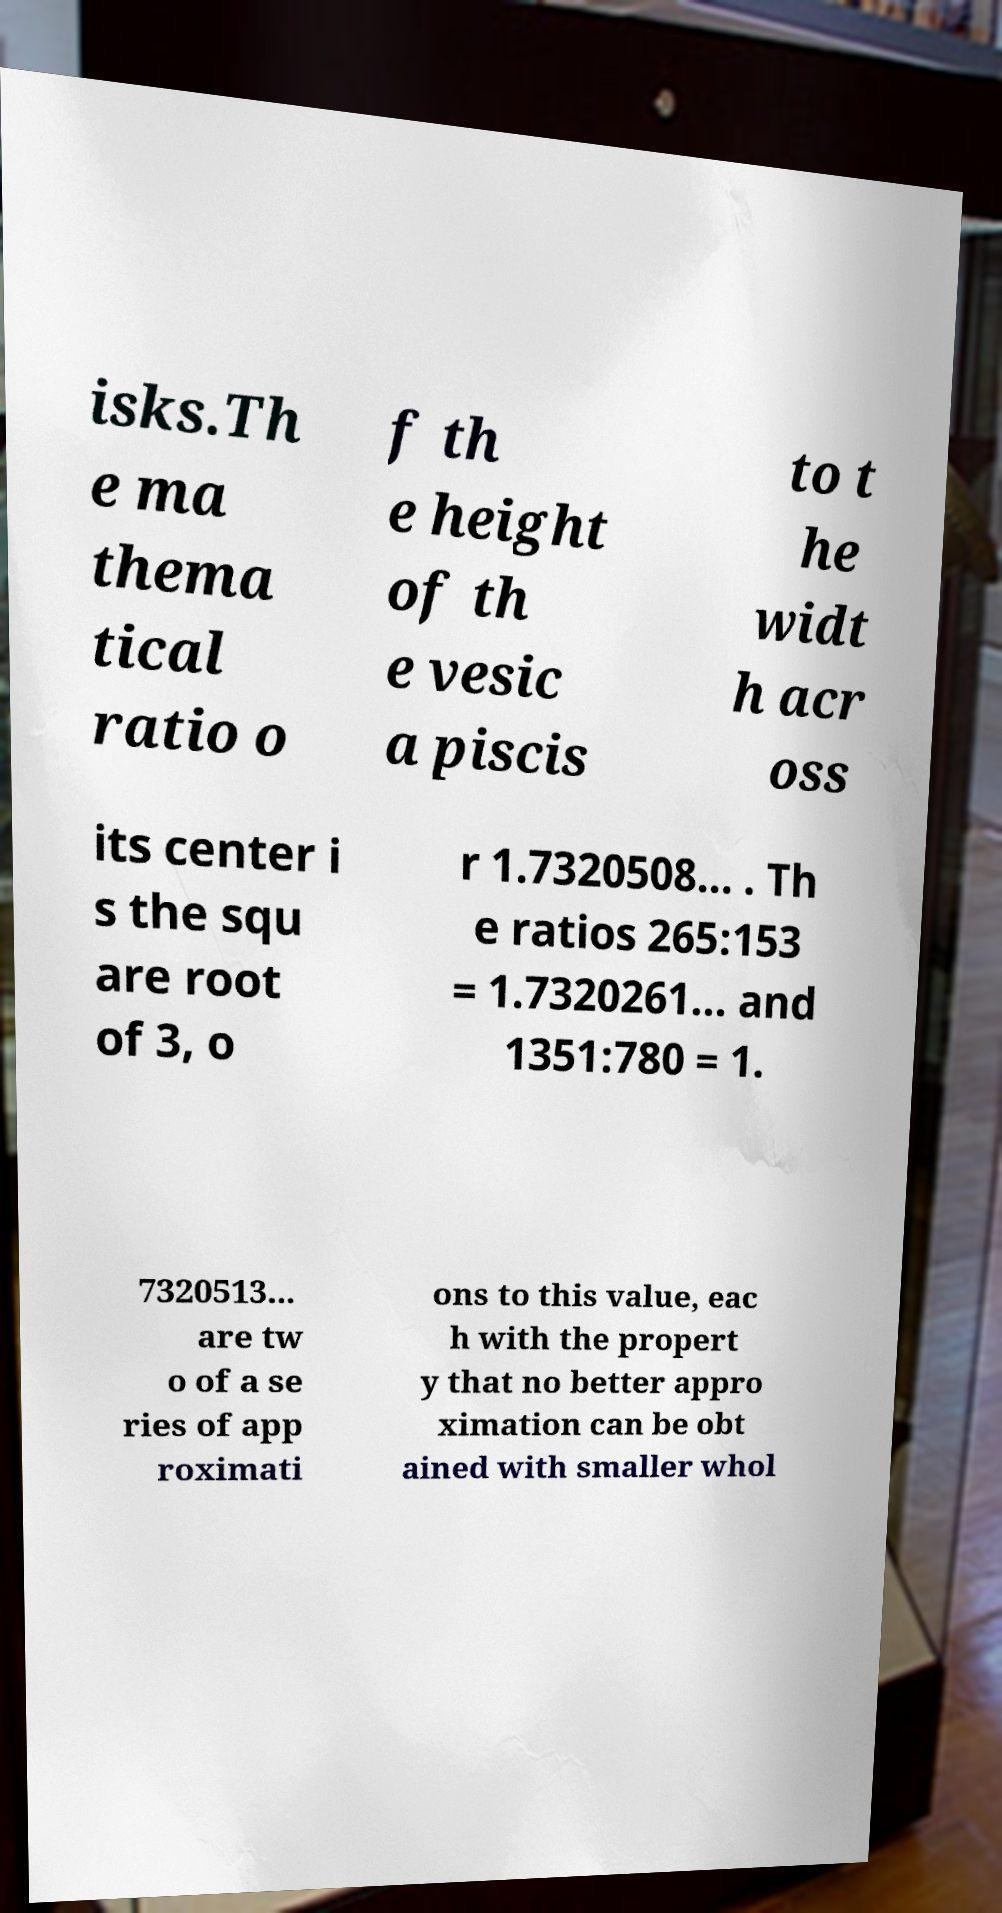Could you extract and type out the text from this image? isks.Th e ma thema tical ratio o f th e height of th e vesic a piscis to t he widt h acr oss its center i s the squ are root of 3, o r 1.7320508... . Th e ratios 265:153 = 1.7320261... and 1351:780 = 1. 7320513... are tw o of a se ries of app roximati ons to this value, eac h with the propert y that no better appro ximation can be obt ained with smaller whol 